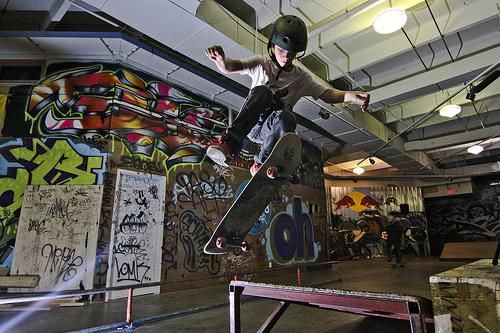What color is the helmet the boy is wearing, and what are the X and Y coordinates of the helmet? The boy is wearing a black helmet, with X coordinates at 265 and Y coordinates at 15. Describe the environment where the skater is performing. The skater is performing tricks indoors, at a skate park with graffiti on the walls, skateboard ramps, and railings. Based on the information given, briefly evaluate the quality of the image. The image is likely to be of high quality, as it contains detailed information about different elements, their colors, and their positions (X, Y coordinates). Count the total number of visible people in the image. There are two people visible in the image. Analyze the sentiment of the image. The image conveys an exciting and positive atmosphere, as the boy enjoys jumping and performing tricks on his skateboard. What does the graffiti on the back wall say, and what colors are used? The graffiti on the back wall says "oh", and it's drawn in blue. Identify the activity the boy is engaged in and provide a brief description of his appearance. The boy is jumping on his skateboard, performing tricks. He's wearing a black helmet. Is the boy doing a trick on a green skateboard? The actual color of the skateboard is not mentioned and none of the captions suggest it to be green. Is there a dog walking in the background? There are captions describing people walking, but no mention of a dog walking. Are the light fixtures on the ceiling off? The captions specifically mention light fixtures overhead being "on," not "off." Is there a yellow wall with graffiti in the background? The wall with graffiti is described as multicolored, but there is no specific mention of it being yellow. Does the skateboard have blue wheels? The captions describe the skateboard wheels as red, not blue. Can you see a girl jumping on a skateboard in the image? All the mentioned captions describe a boy jumping on a skateboard, not a girl. 